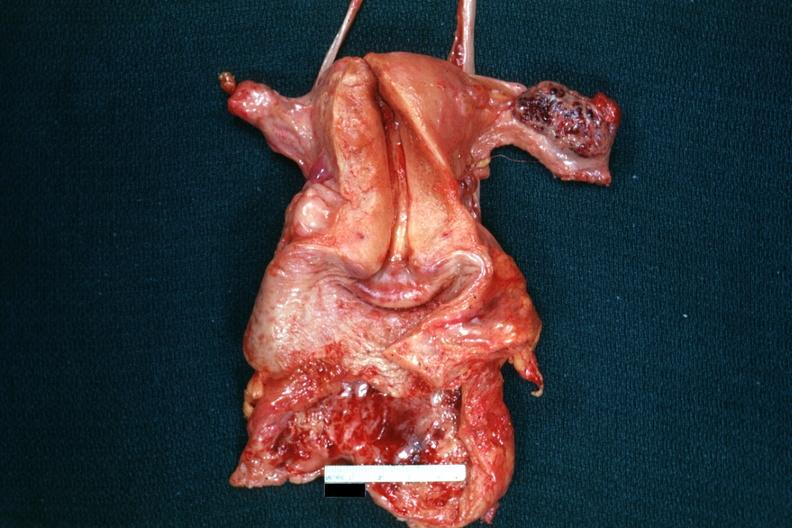s female reproductive present?
Answer the question using a single word or phrase. Yes 